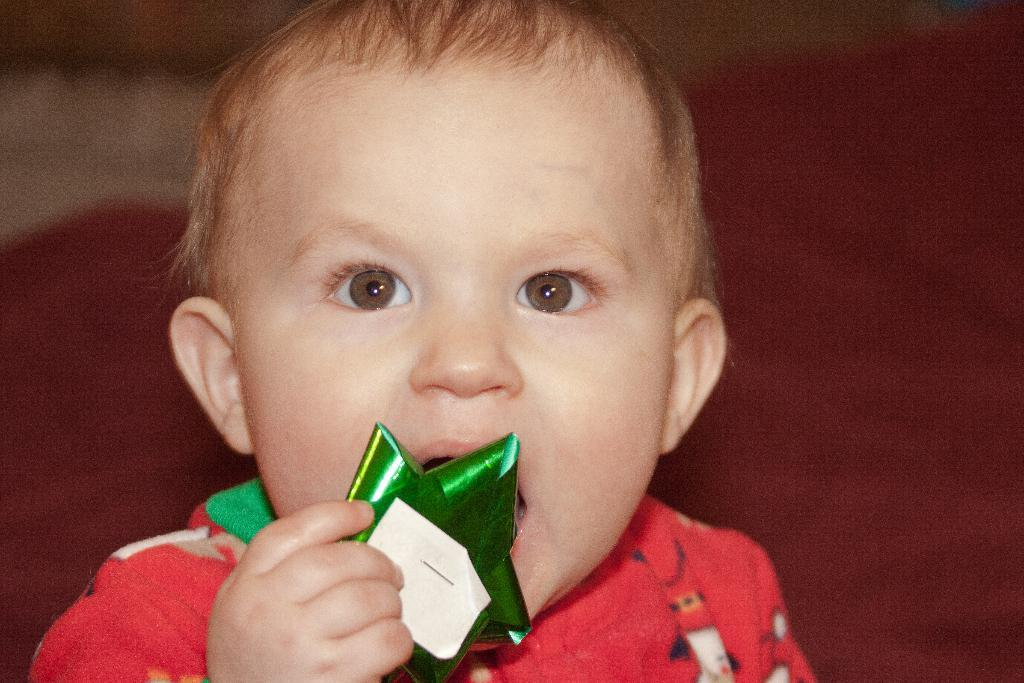What is the main subject of the image? The main subject of the image is a boy. What is the boy holding in his hand? The boy is holding something in his hand, but the specific object cannot be determined from the provided facts. What type of food is the boy eating in the image? There is no information about food in the image, and the boy is not shown eating anything. 